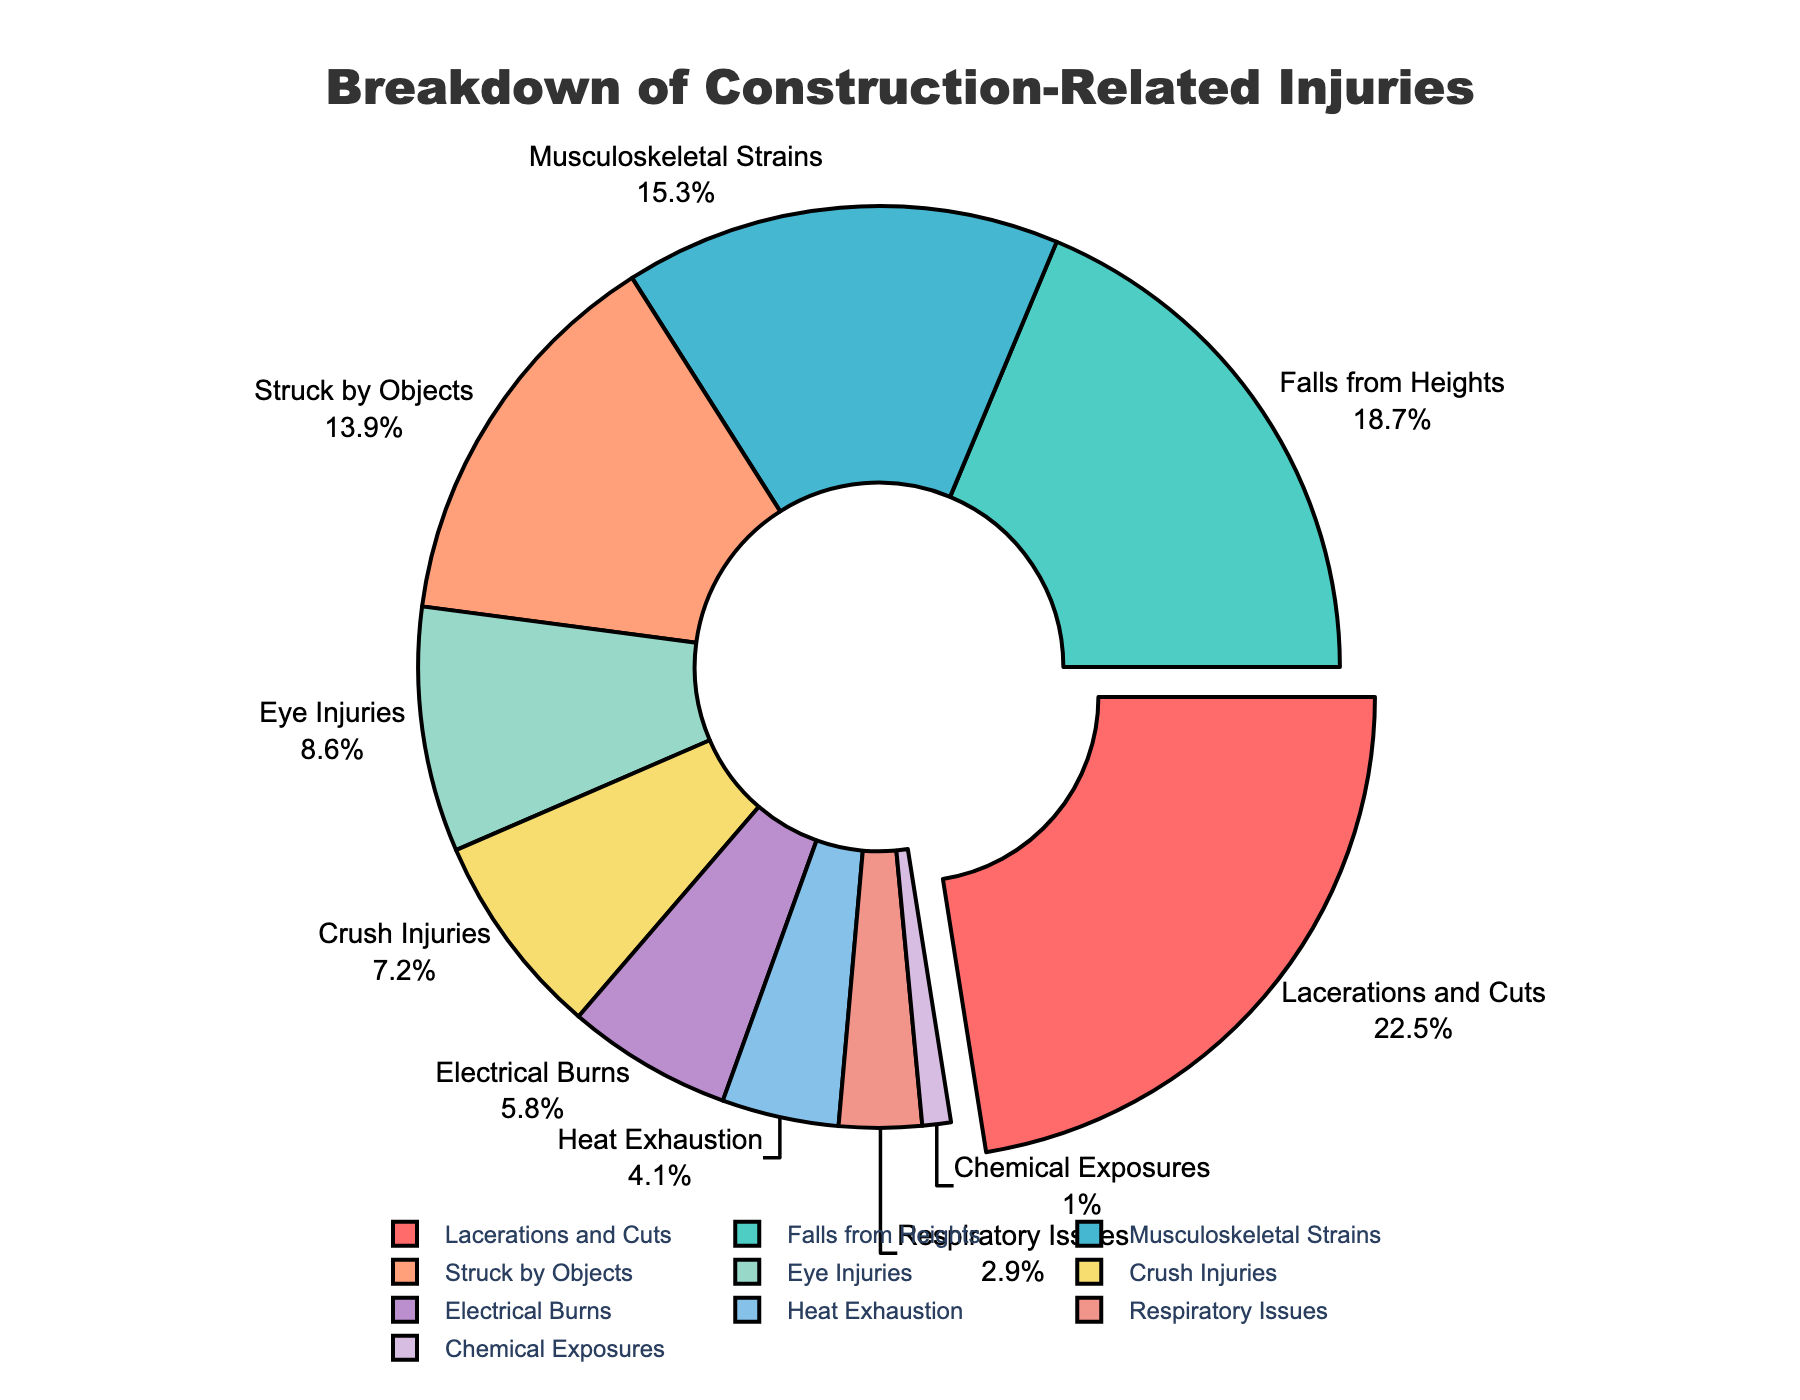What is the most common type of construction-related injury? The figure shows the percentages of various injury types, and the largest section of the pie chart is for Lacerations and Cuts at 22.5%.
Answer: Lacerations and Cuts Which injury type has a lower percentage, Musculoskeletal Strains or Eye Injuries? By comparing the slices corresponding to Musculoskeletal Strains (15.3%) and Eye Injuries (8.6%), Eye Injuries have a lower percentage.
Answer: Eye Injuries What is the combined percentage for Falls from Heights and Struck by Objects? Add the percentages for Falls from Heights (18.7%) and Struck by Objects (13.9%) to get the combined percentage: 18.7% + 13.9% = 32.6%.
Answer: 32.6% Is the percentage of Electrical Burns higher than that of Heat Exhaustion? Compare the percentages for Electrical Burns (5.8%) and Heat Exhaustion (4.1%). Electrical Burns have a higher percentage.
Answer: Yes Which injury type has the smallest percentage? The smallest slice on the pie chart corresponds to Chemical Exposures, with a percentage of 1.0%.
Answer: Chemical Exposures What is the difference in percentage between the most and least common injuries? Subtract the percentage of the least common injury (Chemical Exposures, 1.0%) from the most common injury (Lacerations and Cuts, 22.5%): 22.5% - 1.0% = 21.5%.
Answer: 21.5% How many injury types have a percentage greater than 10%? The injuries with percentages greater than 10% are Lacerations and Cuts (22.5%), Falls from Heights (18.7%), Musculoskeletal Strains (15.3%), and Struck by Objects (13.9%). Count them to get the total: 4.
Answer: 4 What is the total percentage for injuries related to impacts (Falls from Heights and Struck by Objects combined)? Add the percentages for Falls from Heights (18.7%) and Struck by Objects (13.9%): 18.7% + 13.9% = 32.6%.
Answer: 32.6% Which injury type has a purple-colored section? Identify the purple-colored section in the pie chart, which corresponds to Chemical Exposures, based on the color legend in the figure.
Answer: Chemical Exposures What fraction of the injuries are Respiratory Issues and Chemical Exposures combined? Add the percentages for Respiratory Issues (2.9%) and Chemical Exposures (1.0%) to get the combined fraction: 2.9% + 1.0% = 3.9%. Hence, the fraction is 3.9/100.
Answer: 3.9% 